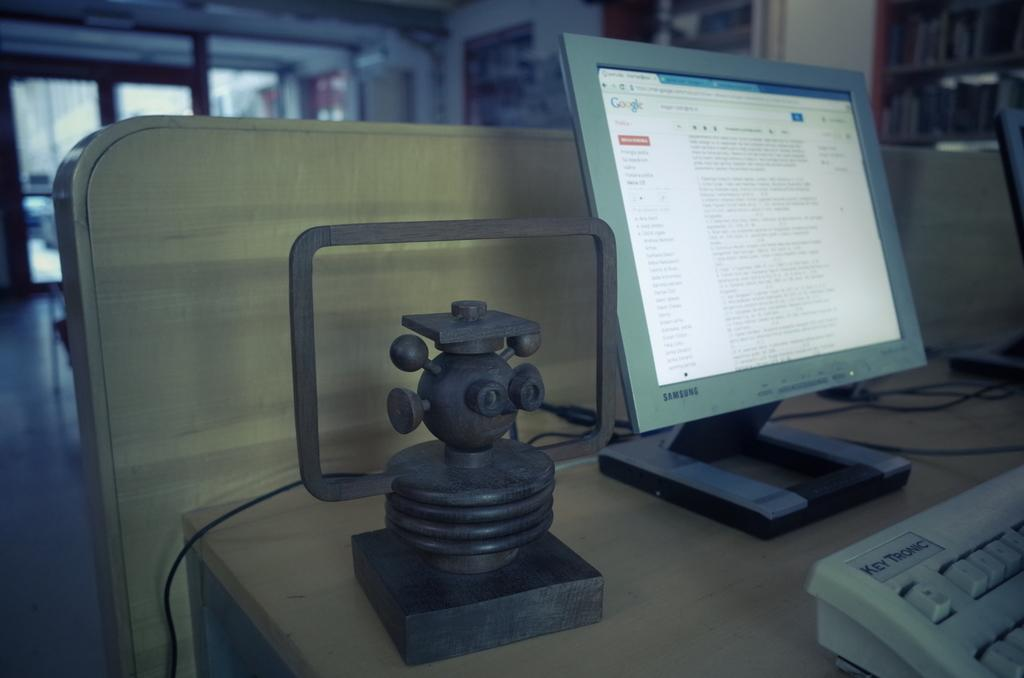<image>
Share a concise interpretation of the image provided. A computer monitor on a desk with Google pulled up on it. 